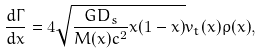Convert formula to latex. <formula><loc_0><loc_0><loc_500><loc_500>\frac { d \Gamma } { d x } = 4 \sqrt { \frac { G D _ { s } } { M ( x ) c ^ { 2 } } x ( 1 - x ) } v _ { t } ( x ) \rho ( x ) ,</formula> 